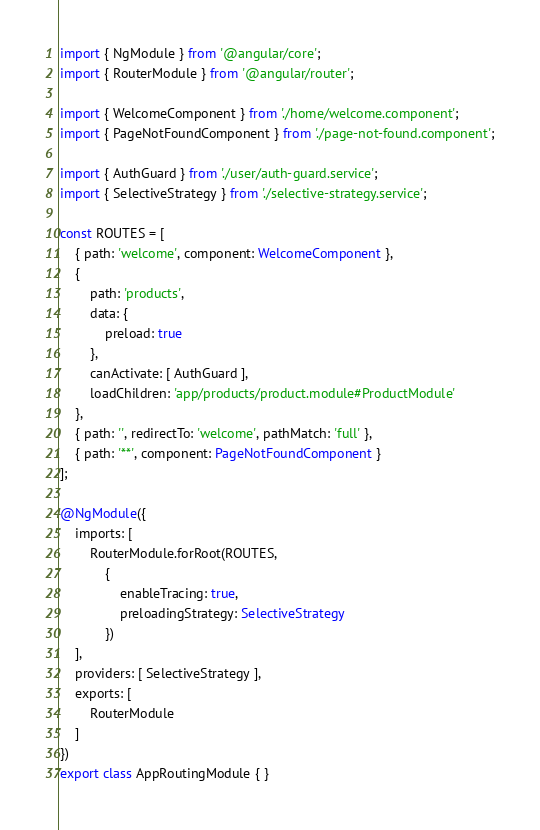Convert code to text. <code><loc_0><loc_0><loc_500><loc_500><_TypeScript_>import { NgModule } from '@angular/core';
import { RouterModule } from '@angular/router';

import { WelcomeComponent } from './home/welcome.component';
import { PageNotFoundComponent } from './page-not-found.component';

import { AuthGuard } from './user/auth-guard.service';
import { SelectiveStrategy } from './selective-strategy.service';

const ROUTES = [
    { path: 'welcome', component: WelcomeComponent },
    {
        path: 'products',
        data: {
            preload: true
        },
        canActivate: [ AuthGuard ],
        loadChildren: 'app/products/product.module#ProductModule'
    },
    { path: '', redirectTo: 'welcome', pathMatch: 'full' },
    { path: '**', component: PageNotFoundComponent }
];

@NgModule({
    imports: [
        RouterModule.forRoot(ROUTES,
            {
                enableTracing: true,
                preloadingStrategy: SelectiveStrategy
            })
    ],
    providers: [ SelectiveStrategy ],
    exports: [
        RouterModule
    ]
})
export class AppRoutingModule { }
</code> 